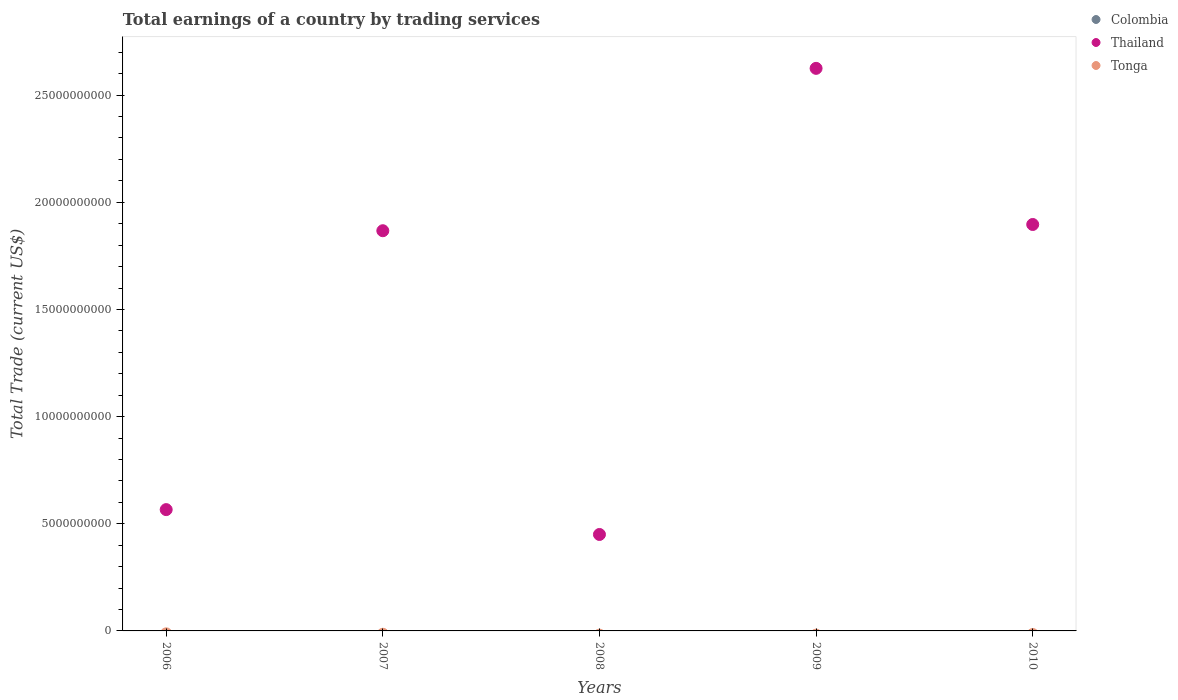How many different coloured dotlines are there?
Offer a very short reply. 1. Is the number of dotlines equal to the number of legend labels?
Make the answer very short. No. What is the total earnings in Colombia in 2007?
Your response must be concise. 0. In which year was the total earnings in Thailand maximum?
Offer a terse response. 2009. What is the total total earnings in Thailand in the graph?
Your response must be concise. 7.40e+1. What is the difference between the total earnings in Thailand in 2008 and that in 2010?
Give a very brief answer. -1.45e+1. What is the average total earnings in Tonga per year?
Provide a succinct answer. 0. What is the ratio of the total earnings in Thailand in 2006 to that in 2007?
Your response must be concise. 0.3. What is the difference between the highest and the second highest total earnings in Thailand?
Your response must be concise. 7.29e+09. What is the difference between the highest and the lowest total earnings in Thailand?
Your answer should be compact. 2.17e+1. In how many years, is the total earnings in Colombia greater than the average total earnings in Colombia taken over all years?
Offer a terse response. 0. Is it the case that in every year, the sum of the total earnings in Thailand and total earnings in Colombia  is greater than the total earnings in Tonga?
Offer a very short reply. Yes. Is the total earnings in Thailand strictly less than the total earnings in Colombia over the years?
Offer a terse response. No. Are the values on the major ticks of Y-axis written in scientific E-notation?
Offer a very short reply. No. Where does the legend appear in the graph?
Offer a terse response. Top right. How many legend labels are there?
Make the answer very short. 3. How are the legend labels stacked?
Ensure brevity in your answer.  Vertical. What is the title of the graph?
Make the answer very short. Total earnings of a country by trading services. What is the label or title of the Y-axis?
Provide a succinct answer. Total Trade (current US$). What is the Total Trade (current US$) in Thailand in 2006?
Ensure brevity in your answer.  5.66e+09. What is the Total Trade (current US$) in Thailand in 2007?
Provide a short and direct response. 1.87e+1. What is the Total Trade (current US$) of Tonga in 2007?
Give a very brief answer. 0. What is the Total Trade (current US$) in Colombia in 2008?
Give a very brief answer. 0. What is the Total Trade (current US$) in Thailand in 2008?
Provide a short and direct response. 4.50e+09. What is the Total Trade (current US$) of Tonga in 2008?
Provide a succinct answer. 0. What is the Total Trade (current US$) in Thailand in 2009?
Your answer should be compact. 2.62e+1. What is the Total Trade (current US$) of Colombia in 2010?
Your response must be concise. 0. What is the Total Trade (current US$) in Thailand in 2010?
Provide a succinct answer. 1.90e+1. Across all years, what is the maximum Total Trade (current US$) of Thailand?
Keep it short and to the point. 2.62e+1. Across all years, what is the minimum Total Trade (current US$) in Thailand?
Keep it short and to the point. 4.50e+09. What is the total Total Trade (current US$) of Colombia in the graph?
Provide a succinct answer. 0. What is the total Total Trade (current US$) in Thailand in the graph?
Your answer should be compact. 7.40e+1. What is the total Total Trade (current US$) of Tonga in the graph?
Your answer should be very brief. 0. What is the difference between the Total Trade (current US$) in Thailand in 2006 and that in 2007?
Your response must be concise. -1.30e+1. What is the difference between the Total Trade (current US$) in Thailand in 2006 and that in 2008?
Keep it short and to the point. 1.16e+09. What is the difference between the Total Trade (current US$) in Thailand in 2006 and that in 2009?
Ensure brevity in your answer.  -2.06e+1. What is the difference between the Total Trade (current US$) of Thailand in 2006 and that in 2010?
Give a very brief answer. -1.33e+1. What is the difference between the Total Trade (current US$) in Thailand in 2007 and that in 2008?
Provide a succinct answer. 1.42e+1. What is the difference between the Total Trade (current US$) of Thailand in 2007 and that in 2009?
Offer a very short reply. -7.58e+09. What is the difference between the Total Trade (current US$) in Thailand in 2007 and that in 2010?
Make the answer very short. -2.91e+08. What is the difference between the Total Trade (current US$) of Thailand in 2008 and that in 2009?
Make the answer very short. -2.17e+1. What is the difference between the Total Trade (current US$) in Thailand in 2008 and that in 2010?
Your response must be concise. -1.45e+1. What is the difference between the Total Trade (current US$) of Thailand in 2009 and that in 2010?
Provide a succinct answer. 7.29e+09. What is the average Total Trade (current US$) of Colombia per year?
Make the answer very short. 0. What is the average Total Trade (current US$) of Thailand per year?
Make the answer very short. 1.48e+1. What is the average Total Trade (current US$) of Tonga per year?
Give a very brief answer. 0. What is the ratio of the Total Trade (current US$) in Thailand in 2006 to that in 2007?
Your response must be concise. 0.3. What is the ratio of the Total Trade (current US$) of Thailand in 2006 to that in 2008?
Make the answer very short. 1.26. What is the ratio of the Total Trade (current US$) of Thailand in 2006 to that in 2009?
Give a very brief answer. 0.22. What is the ratio of the Total Trade (current US$) in Thailand in 2006 to that in 2010?
Offer a very short reply. 0.3. What is the ratio of the Total Trade (current US$) of Thailand in 2007 to that in 2008?
Offer a terse response. 4.15. What is the ratio of the Total Trade (current US$) in Thailand in 2007 to that in 2009?
Your answer should be very brief. 0.71. What is the ratio of the Total Trade (current US$) of Thailand in 2007 to that in 2010?
Keep it short and to the point. 0.98. What is the ratio of the Total Trade (current US$) in Thailand in 2008 to that in 2009?
Your answer should be compact. 0.17. What is the ratio of the Total Trade (current US$) in Thailand in 2008 to that in 2010?
Provide a short and direct response. 0.24. What is the ratio of the Total Trade (current US$) in Thailand in 2009 to that in 2010?
Offer a terse response. 1.38. What is the difference between the highest and the second highest Total Trade (current US$) of Thailand?
Your answer should be compact. 7.29e+09. What is the difference between the highest and the lowest Total Trade (current US$) of Thailand?
Offer a terse response. 2.17e+1. 